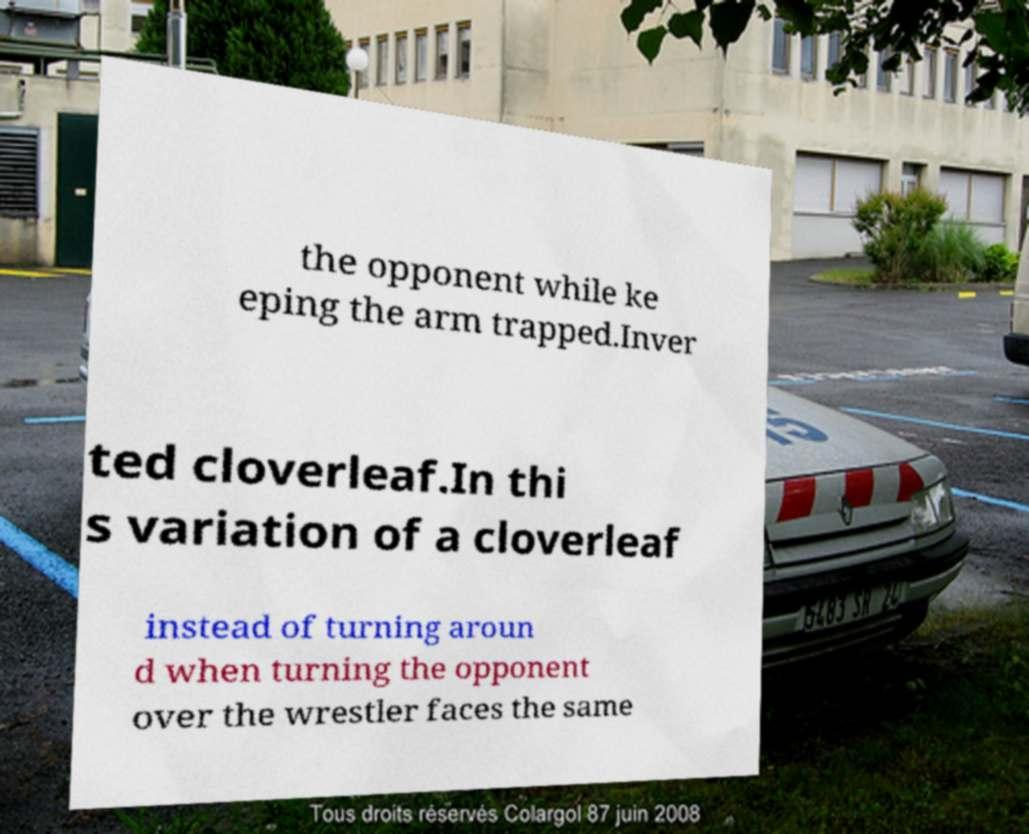For documentation purposes, I need the text within this image transcribed. Could you provide that? the opponent while ke eping the arm trapped.Inver ted cloverleaf.In thi s variation of a cloverleaf instead of turning aroun d when turning the opponent over the wrestler faces the same 